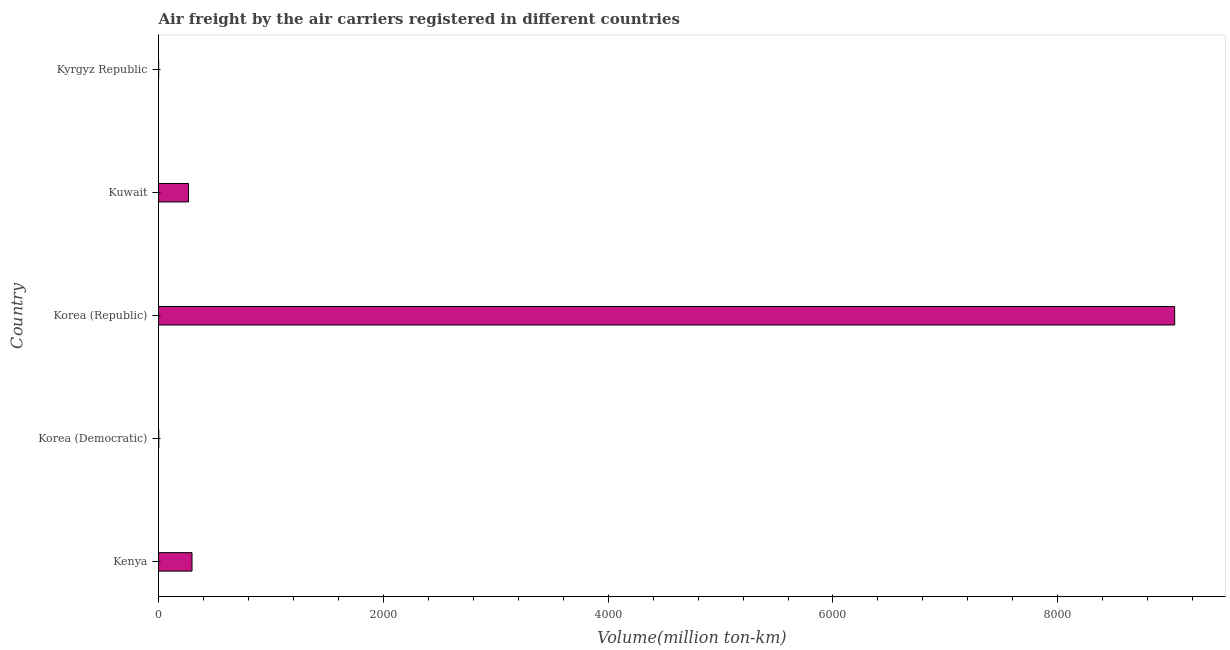What is the title of the graph?
Make the answer very short. Air freight by the air carriers registered in different countries. What is the label or title of the X-axis?
Your response must be concise. Volume(million ton-km). What is the label or title of the Y-axis?
Keep it short and to the point. Country. What is the air freight in Korea (Republic)?
Your answer should be compact. 9039.72. Across all countries, what is the maximum air freight?
Make the answer very short. 9039.72. Across all countries, what is the minimum air freight?
Your answer should be very brief. 1.23. In which country was the air freight maximum?
Ensure brevity in your answer.  Korea (Republic). In which country was the air freight minimum?
Offer a terse response. Kyrgyz Republic. What is the sum of the air freight?
Keep it short and to the point. 9607.79. What is the difference between the air freight in Kenya and Kuwait?
Make the answer very short. 31.75. What is the average air freight per country?
Give a very brief answer. 1921.56. What is the median air freight?
Your answer should be compact. 266.34. In how many countries, is the air freight greater than 8800 million ton-km?
Make the answer very short. 1. What is the ratio of the air freight in Korea (Democratic) to that in Kyrgyz Republic?
Your answer should be very brief. 1.97. Is the difference between the air freight in Kenya and Korea (Republic) greater than the difference between any two countries?
Give a very brief answer. No. What is the difference between the highest and the second highest air freight?
Your answer should be compact. 8741.64. What is the difference between the highest and the lowest air freight?
Make the answer very short. 9038.49. Are all the bars in the graph horizontal?
Make the answer very short. Yes. Are the values on the major ticks of X-axis written in scientific E-notation?
Your answer should be compact. No. What is the Volume(million ton-km) in Kenya?
Your answer should be compact. 298.08. What is the Volume(million ton-km) in Korea (Democratic)?
Offer a very short reply. 2.42. What is the Volume(million ton-km) in Korea (Republic)?
Ensure brevity in your answer.  9039.72. What is the Volume(million ton-km) of Kuwait?
Give a very brief answer. 266.34. What is the Volume(million ton-km) in Kyrgyz Republic?
Ensure brevity in your answer.  1.23. What is the difference between the Volume(million ton-km) in Kenya and Korea (Democratic)?
Your answer should be very brief. 295.66. What is the difference between the Volume(million ton-km) in Kenya and Korea (Republic)?
Your answer should be very brief. -8741.64. What is the difference between the Volume(million ton-km) in Kenya and Kuwait?
Give a very brief answer. 31.75. What is the difference between the Volume(million ton-km) in Kenya and Kyrgyz Republic?
Your response must be concise. 296.85. What is the difference between the Volume(million ton-km) in Korea (Democratic) and Korea (Republic)?
Your response must be concise. -9037.3. What is the difference between the Volume(million ton-km) in Korea (Democratic) and Kuwait?
Your answer should be compact. -263.91. What is the difference between the Volume(million ton-km) in Korea (Democratic) and Kyrgyz Republic?
Give a very brief answer. 1.19. What is the difference between the Volume(million ton-km) in Korea (Republic) and Kuwait?
Your answer should be very brief. 8773.38. What is the difference between the Volume(million ton-km) in Korea (Republic) and Kyrgyz Republic?
Ensure brevity in your answer.  9038.49. What is the difference between the Volume(million ton-km) in Kuwait and Kyrgyz Republic?
Give a very brief answer. 265.11. What is the ratio of the Volume(million ton-km) in Kenya to that in Korea (Democratic)?
Offer a terse response. 123.02. What is the ratio of the Volume(million ton-km) in Kenya to that in Korea (Republic)?
Your response must be concise. 0.03. What is the ratio of the Volume(million ton-km) in Kenya to that in Kuwait?
Give a very brief answer. 1.12. What is the ratio of the Volume(million ton-km) in Kenya to that in Kyrgyz Republic?
Your response must be concise. 242.34. What is the ratio of the Volume(million ton-km) in Korea (Democratic) to that in Kuwait?
Make the answer very short. 0.01. What is the ratio of the Volume(million ton-km) in Korea (Democratic) to that in Kyrgyz Republic?
Your answer should be very brief. 1.97. What is the ratio of the Volume(million ton-km) in Korea (Republic) to that in Kuwait?
Ensure brevity in your answer.  33.94. What is the ratio of the Volume(million ton-km) in Korea (Republic) to that in Kyrgyz Republic?
Offer a very short reply. 7349.37. What is the ratio of the Volume(million ton-km) in Kuwait to that in Kyrgyz Republic?
Make the answer very short. 216.53. 